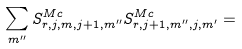<formula> <loc_0><loc_0><loc_500><loc_500>\sum _ { m ^ { \prime \prime } } S ^ { M c } _ { r , j , m , j + 1 , m ^ { \prime \prime } } S ^ { M c } _ { r , j + 1 , m ^ { \prime \prime } , j , m ^ { \prime } } =</formula> 